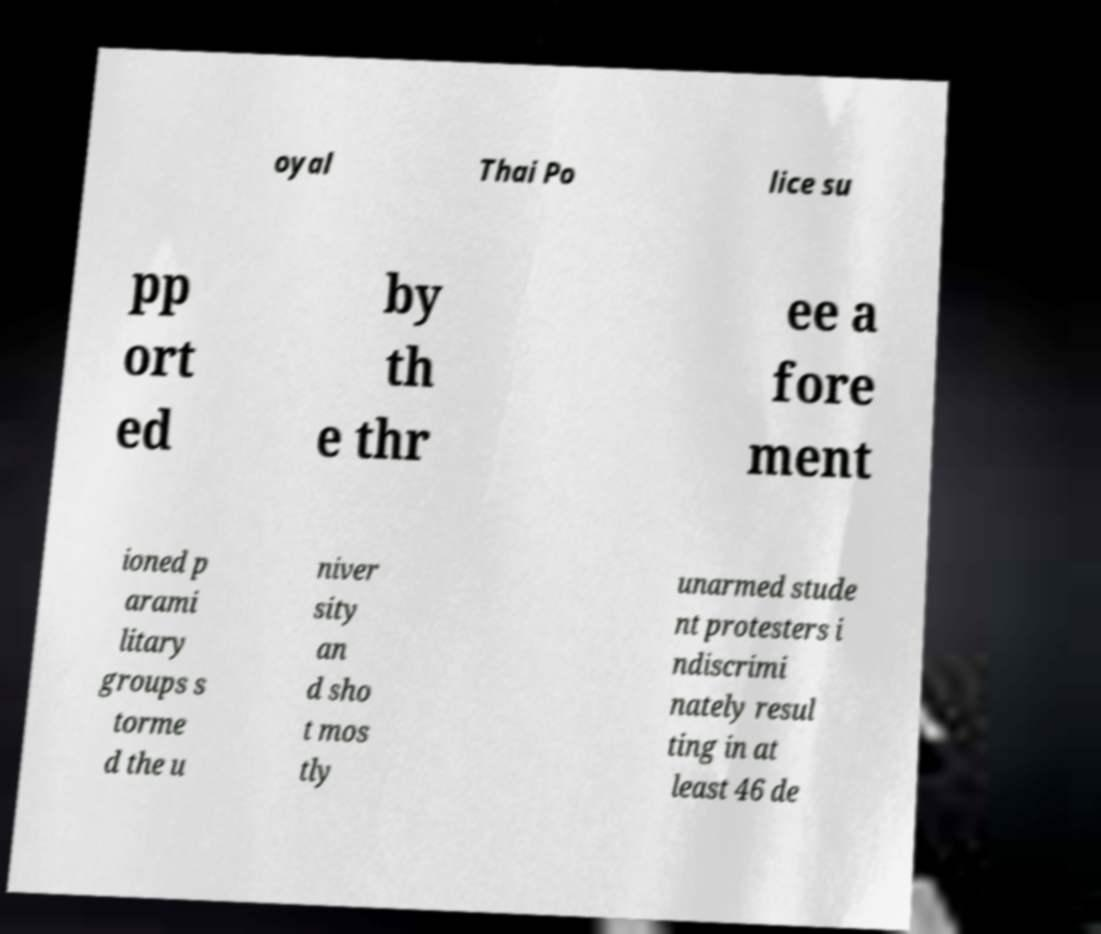Please read and relay the text visible in this image. What does it say? oyal Thai Po lice su pp ort ed by th e thr ee a fore ment ioned p arami litary groups s torme d the u niver sity an d sho t mos tly unarmed stude nt protesters i ndiscrimi nately resul ting in at least 46 de 